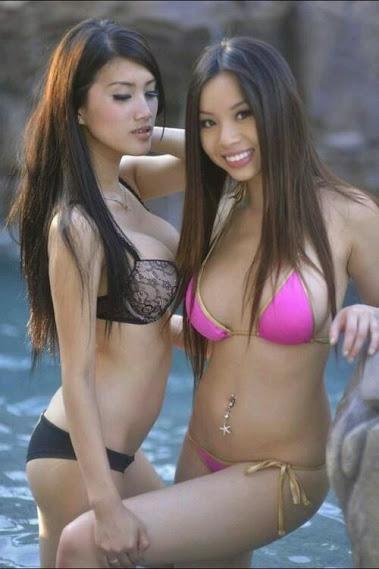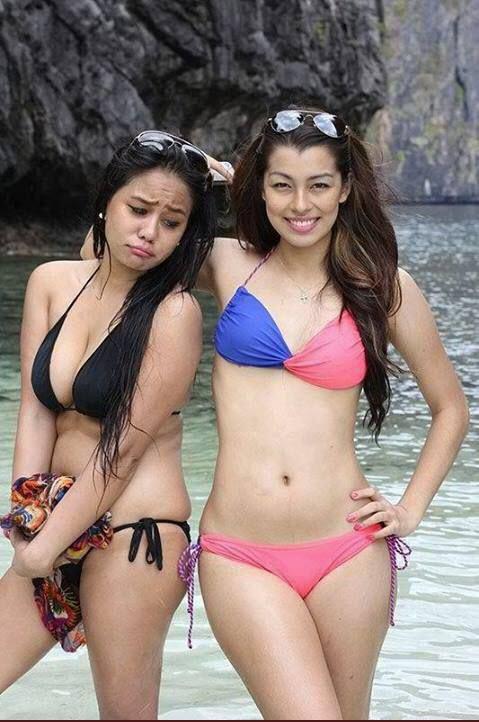The first image is the image on the left, the second image is the image on the right. Given the left and right images, does the statement "There are an equal number of girls in both images." hold true? Answer yes or no. Yes. The first image is the image on the left, the second image is the image on the right. Analyze the images presented: Is the assertion "The combined images contain four bikini models, and none have sunglasses covering their eyes." valid? Answer yes or no. Yes. 